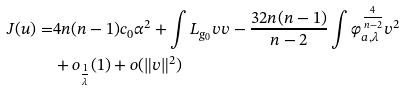<formula> <loc_0><loc_0><loc_500><loc_500>J ( u ) = & 4 n ( n - 1 ) c _ { 0 } \alpha ^ { 2 } + \int L _ { g _ { 0 } } v v - \frac { 3 2 n ( n - 1 ) } { n - 2 } \int \varphi _ { a , \lambda } ^ { \frac { 4 } { n - 2 } } v ^ { 2 } \\ & + o _ { \frac { 1 } { \lambda } } ( 1 ) + o ( \| v \| ^ { 2 } )</formula> 